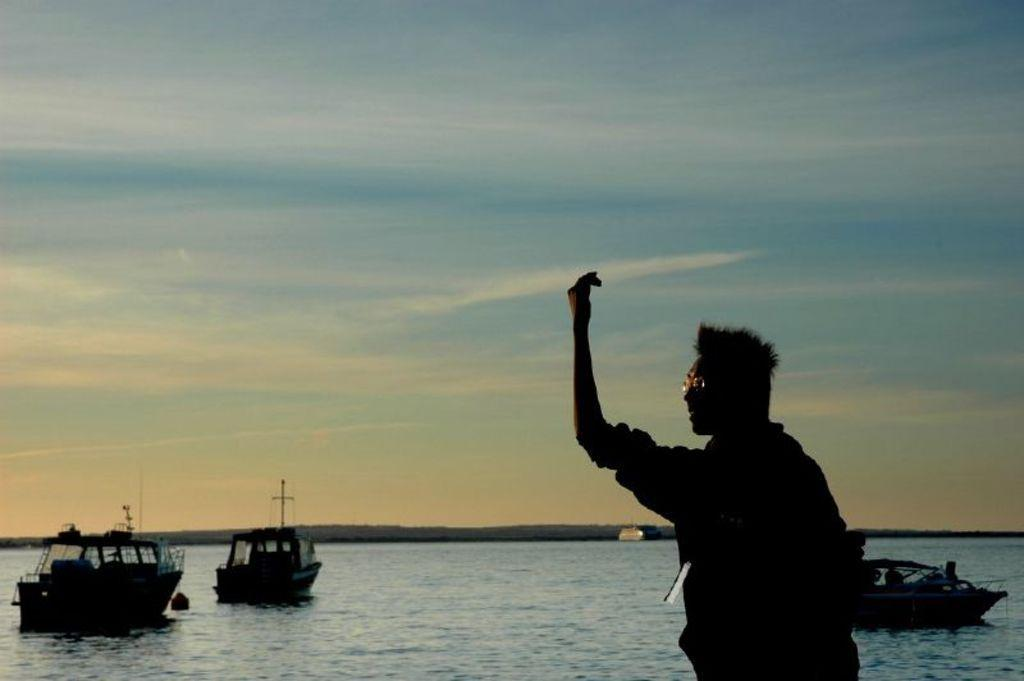What is the main subject of the image? There is a person in the image. What can be seen in the water in the image? There are boats on water in the image. What is visible in the background of the image? The sky is visible in the background of the image. Can you tell me how many kittens are playing with a clam in the image? There are no kittens or clams present in the image; it features a person and boats on water. 